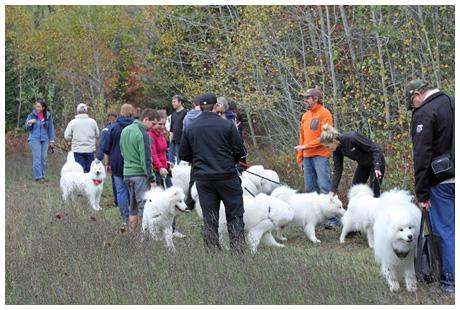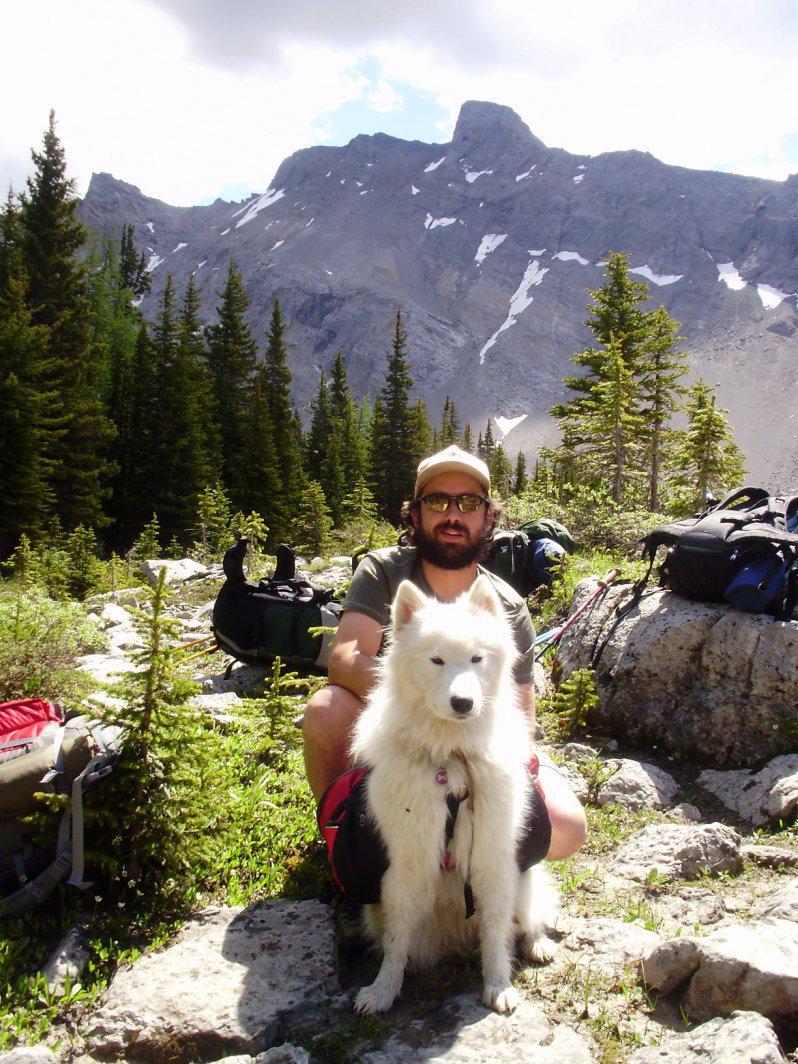The first image is the image on the left, the second image is the image on the right. Assess this claim about the two images: "White dogs are standing on a rocky edge.". Correct or not? Answer yes or no. No. The first image is the image on the left, the second image is the image on the right. Evaluate the accuracy of this statement regarding the images: "AN image shows just one person posed behind one big white dog outdoors.". Is it true? Answer yes or no. Yes. 